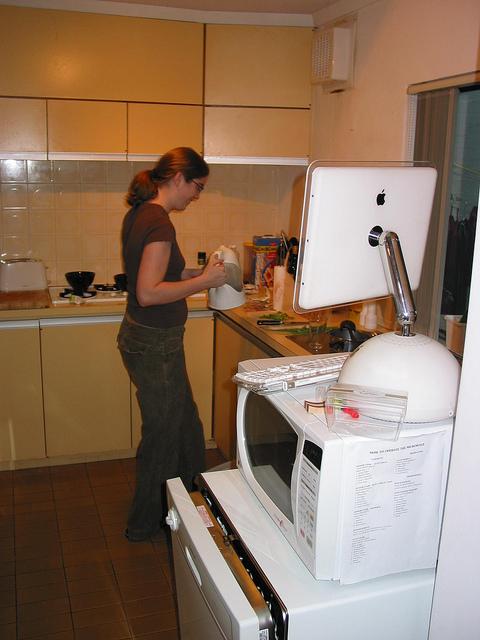What color are the appliances?
Be succinct. White. What room is the woman in?
Answer briefly. Kitchen. Which woman is cooking?
Short answer required. Only one. Is there an apple computer in this room?
Write a very short answer. Yes. 